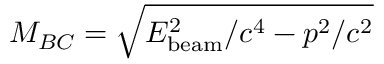Convert formula to latex. <formula><loc_0><loc_0><loc_500><loc_500>M _ { B C } = \sqrt { E _ { b e a m } ^ { 2 } / c ^ { 4 } - p ^ { 2 } / c ^ { 2 } }</formula> 